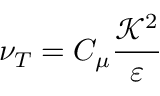Convert formula to latex. <formula><loc_0><loc_0><loc_500><loc_500>\nu _ { T } = C _ { \mu } \frac { \mathcal { K } ^ { 2 } } { \varepsilon }</formula> 